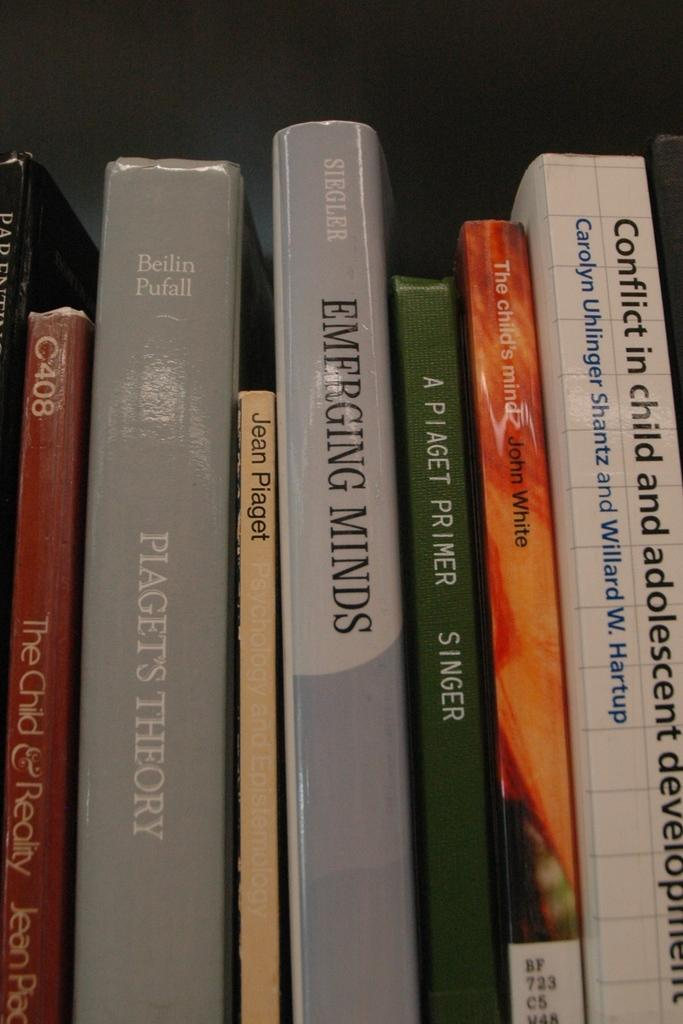<image>
Describe the image concisely. A couple of books which titles include Emerging Minds and Piaget's Theory. 